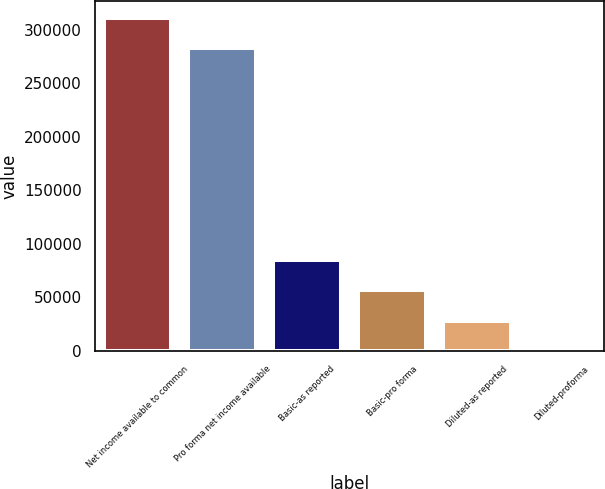Convert chart to OTSL. <chart><loc_0><loc_0><loc_500><loc_500><bar_chart><fcel>Net income available to common<fcel>Pro forma net income available<fcel>Basic-as reported<fcel>Basic-pro forma<fcel>Diluted-as reported<fcel>Diluted-proforma<nl><fcel>310861<fcel>282460<fcel>85206.9<fcel>56805.5<fcel>28404<fcel>2.6<nl></chart> 